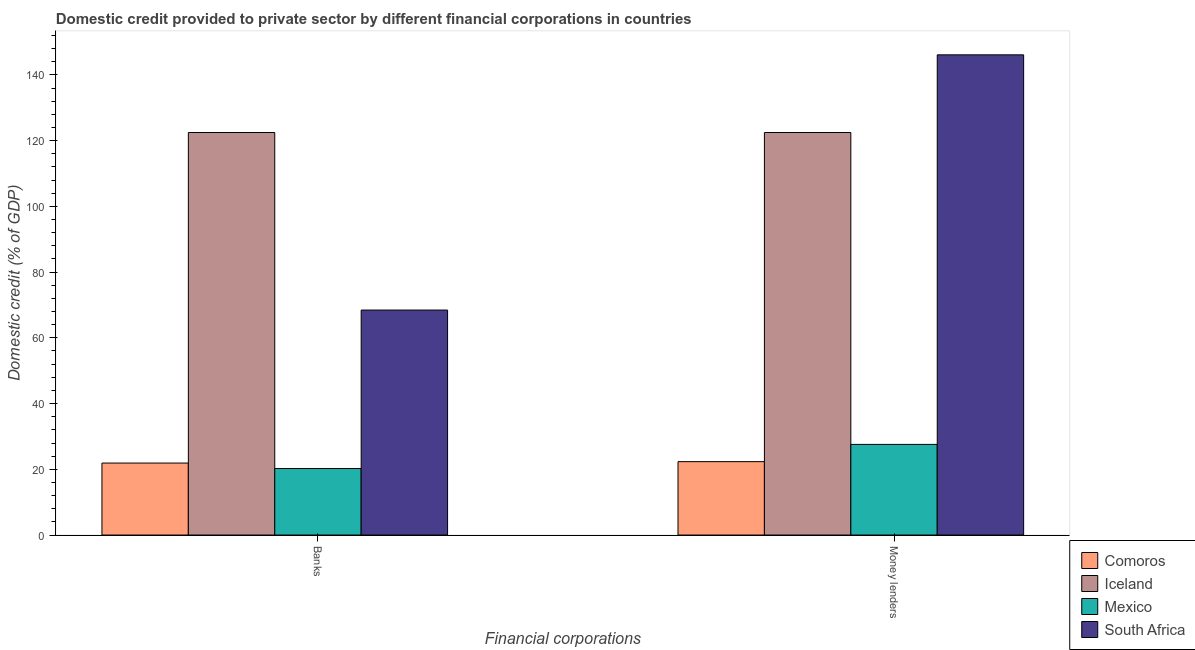How many different coloured bars are there?
Provide a short and direct response. 4. How many groups of bars are there?
Offer a very short reply. 2. Are the number of bars on each tick of the X-axis equal?
Provide a succinct answer. Yes. What is the label of the 2nd group of bars from the left?
Keep it short and to the point. Money lenders. What is the domestic credit provided by money lenders in Comoros?
Provide a short and direct response. 22.33. Across all countries, what is the maximum domestic credit provided by money lenders?
Your answer should be compact. 146.09. Across all countries, what is the minimum domestic credit provided by money lenders?
Your response must be concise. 22.33. In which country was the domestic credit provided by money lenders maximum?
Ensure brevity in your answer.  South Africa. In which country was the domestic credit provided by banks minimum?
Make the answer very short. Mexico. What is the total domestic credit provided by banks in the graph?
Your answer should be compact. 233.04. What is the difference between the domestic credit provided by banks in South Africa and that in Comoros?
Provide a short and direct response. 46.55. What is the difference between the domestic credit provided by money lenders in Comoros and the domestic credit provided by banks in South Africa?
Offer a very short reply. -46.12. What is the average domestic credit provided by money lenders per country?
Ensure brevity in your answer.  79.61. What is the difference between the domestic credit provided by banks and domestic credit provided by money lenders in Mexico?
Offer a terse response. -7.34. What is the ratio of the domestic credit provided by money lenders in South Africa to that in Comoros?
Give a very brief answer. 6.54. Is the domestic credit provided by money lenders in South Africa less than that in Mexico?
Ensure brevity in your answer.  No. In how many countries, is the domestic credit provided by money lenders greater than the average domestic credit provided by money lenders taken over all countries?
Make the answer very short. 2. What does the 4th bar from the right in Banks represents?
Provide a succinct answer. Comoros. How many countries are there in the graph?
Provide a succinct answer. 4. Does the graph contain any zero values?
Your answer should be very brief. No. Does the graph contain grids?
Your answer should be compact. No. How are the legend labels stacked?
Your response must be concise. Vertical. What is the title of the graph?
Make the answer very short. Domestic credit provided to private sector by different financial corporations in countries. Does "South Sudan" appear as one of the legend labels in the graph?
Your answer should be compact. No. What is the label or title of the X-axis?
Make the answer very short. Financial corporations. What is the label or title of the Y-axis?
Offer a terse response. Domestic credit (% of GDP). What is the Domestic credit (% of GDP) in Comoros in Banks?
Your answer should be compact. 21.9. What is the Domestic credit (% of GDP) in Iceland in Banks?
Your response must be concise. 122.46. What is the Domestic credit (% of GDP) in Mexico in Banks?
Your response must be concise. 20.24. What is the Domestic credit (% of GDP) in South Africa in Banks?
Offer a terse response. 68.45. What is the Domestic credit (% of GDP) of Comoros in Money lenders?
Offer a terse response. 22.33. What is the Domestic credit (% of GDP) in Iceland in Money lenders?
Offer a terse response. 122.46. What is the Domestic credit (% of GDP) of Mexico in Money lenders?
Offer a terse response. 27.57. What is the Domestic credit (% of GDP) in South Africa in Money lenders?
Make the answer very short. 146.09. Across all Financial corporations, what is the maximum Domestic credit (% of GDP) in Comoros?
Make the answer very short. 22.33. Across all Financial corporations, what is the maximum Domestic credit (% of GDP) of Iceland?
Your response must be concise. 122.46. Across all Financial corporations, what is the maximum Domestic credit (% of GDP) in Mexico?
Provide a short and direct response. 27.57. Across all Financial corporations, what is the maximum Domestic credit (% of GDP) of South Africa?
Keep it short and to the point. 146.09. Across all Financial corporations, what is the minimum Domestic credit (% of GDP) of Comoros?
Provide a short and direct response. 21.9. Across all Financial corporations, what is the minimum Domestic credit (% of GDP) of Iceland?
Your response must be concise. 122.46. Across all Financial corporations, what is the minimum Domestic credit (% of GDP) of Mexico?
Give a very brief answer. 20.24. Across all Financial corporations, what is the minimum Domestic credit (% of GDP) of South Africa?
Your response must be concise. 68.45. What is the total Domestic credit (% of GDP) in Comoros in the graph?
Keep it short and to the point. 44.23. What is the total Domestic credit (% of GDP) of Iceland in the graph?
Ensure brevity in your answer.  244.92. What is the total Domestic credit (% of GDP) of Mexico in the graph?
Ensure brevity in your answer.  47.81. What is the total Domestic credit (% of GDP) in South Africa in the graph?
Keep it short and to the point. 214.54. What is the difference between the Domestic credit (% of GDP) of Comoros in Banks and that in Money lenders?
Offer a very short reply. -0.43. What is the difference between the Domestic credit (% of GDP) in Iceland in Banks and that in Money lenders?
Keep it short and to the point. 0. What is the difference between the Domestic credit (% of GDP) of Mexico in Banks and that in Money lenders?
Keep it short and to the point. -7.34. What is the difference between the Domestic credit (% of GDP) of South Africa in Banks and that in Money lenders?
Provide a succinct answer. -77.64. What is the difference between the Domestic credit (% of GDP) in Comoros in Banks and the Domestic credit (% of GDP) in Iceland in Money lenders?
Ensure brevity in your answer.  -100.56. What is the difference between the Domestic credit (% of GDP) in Comoros in Banks and the Domestic credit (% of GDP) in Mexico in Money lenders?
Your answer should be very brief. -5.67. What is the difference between the Domestic credit (% of GDP) of Comoros in Banks and the Domestic credit (% of GDP) of South Africa in Money lenders?
Your answer should be very brief. -124.19. What is the difference between the Domestic credit (% of GDP) in Iceland in Banks and the Domestic credit (% of GDP) in Mexico in Money lenders?
Give a very brief answer. 94.89. What is the difference between the Domestic credit (% of GDP) of Iceland in Banks and the Domestic credit (% of GDP) of South Africa in Money lenders?
Offer a terse response. -23.63. What is the difference between the Domestic credit (% of GDP) in Mexico in Banks and the Domestic credit (% of GDP) in South Africa in Money lenders?
Ensure brevity in your answer.  -125.85. What is the average Domestic credit (% of GDP) of Comoros per Financial corporations?
Offer a very short reply. 22.11. What is the average Domestic credit (% of GDP) in Iceland per Financial corporations?
Ensure brevity in your answer.  122.46. What is the average Domestic credit (% of GDP) in Mexico per Financial corporations?
Offer a very short reply. 23.91. What is the average Domestic credit (% of GDP) of South Africa per Financial corporations?
Make the answer very short. 107.27. What is the difference between the Domestic credit (% of GDP) in Comoros and Domestic credit (% of GDP) in Iceland in Banks?
Your response must be concise. -100.56. What is the difference between the Domestic credit (% of GDP) of Comoros and Domestic credit (% of GDP) of Mexico in Banks?
Ensure brevity in your answer.  1.66. What is the difference between the Domestic credit (% of GDP) of Comoros and Domestic credit (% of GDP) of South Africa in Banks?
Your answer should be very brief. -46.55. What is the difference between the Domestic credit (% of GDP) of Iceland and Domestic credit (% of GDP) of Mexico in Banks?
Ensure brevity in your answer.  102.22. What is the difference between the Domestic credit (% of GDP) in Iceland and Domestic credit (% of GDP) in South Africa in Banks?
Give a very brief answer. 54.01. What is the difference between the Domestic credit (% of GDP) in Mexico and Domestic credit (% of GDP) in South Africa in Banks?
Keep it short and to the point. -48.21. What is the difference between the Domestic credit (% of GDP) in Comoros and Domestic credit (% of GDP) in Iceland in Money lenders?
Provide a succinct answer. -100.13. What is the difference between the Domestic credit (% of GDP) in Comoros and Domestic credit (% of GDP) in Mexico in Money lenders?
Ensure brevity in your answer.  -5.25. What is the difference between the Domestic credit (% of GDP) in Comoros and Domestic credit (% of GDP) in South Africa in Money lenders?
Ensure brevity in your answer.  -123.76. What is the difference between the Domestic credit (% of GDP) of Iceland and Domestic credit (% of GDP) of Mexico in Money lenders?
Make the answer very short. 94.89. What is the difference between the Domestic credit (% of GDP) in Iceland and Domestic credit (% of GDP) in South Africa in Money lenders?
Keep it short and to the point. -23.63. What is the difference between the Domestic credit (% of GDP) of Mexico and Domestic credit (% of GDP) of South Africa in Money lenders?
Provide a succinct answer. -118.52. What is the ratio of the Domestic credit (% of GDP) of Comoros in Banks to that in Money lenders?
Give a very brief answer. 0.98. What is the ratio of the Domestic credit (% of GDP) in Iceland in Banks to that in Money lenders?
Make the answer very short. 1. What is the ratio of the Domestic credit (% of GDP) in Mexico in Banks to that in Money lenders?
Your response must be concise. 0.73. What is the ratio of the Domestic credit (% of GDP) in South Africa in Banks to that in Money lenders?
Your response must be concise. 0.47. What is the difference between the highest and the second highest Domestic credit (% of GDP) in Comoros?
Give a very brief answer. 0.43. What is the difference between the highest and the second highest Domestic credit (% of GDP) of Mexico?
Offer a terse response. 7.34. What is the difference between the highest and the second highest Domestic credit (% of GDP) of South Africa?
Your answer should be compact. 77.64. What is the difference between the highest and the lowest Domestic credit (% of GDP) of Comoros?
Your response must be concise. 0.43. What is the difference between the highest and the lowest Domestic credit (% of GDP) in Mexico?
Your answer should be compact. 7.34. What is the difference between the highest and the lowest Domestic credit (% of GDP) in South Africa?
Offer a terse response. 77.64. 